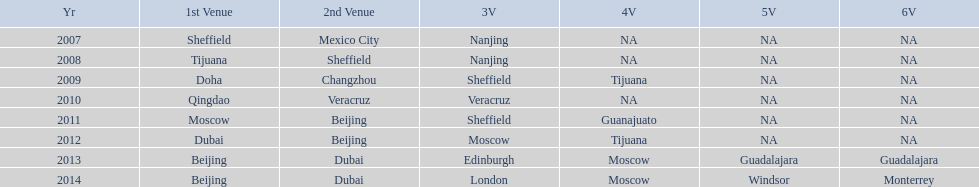What was the last year where tijuana was a venue? 2012. 